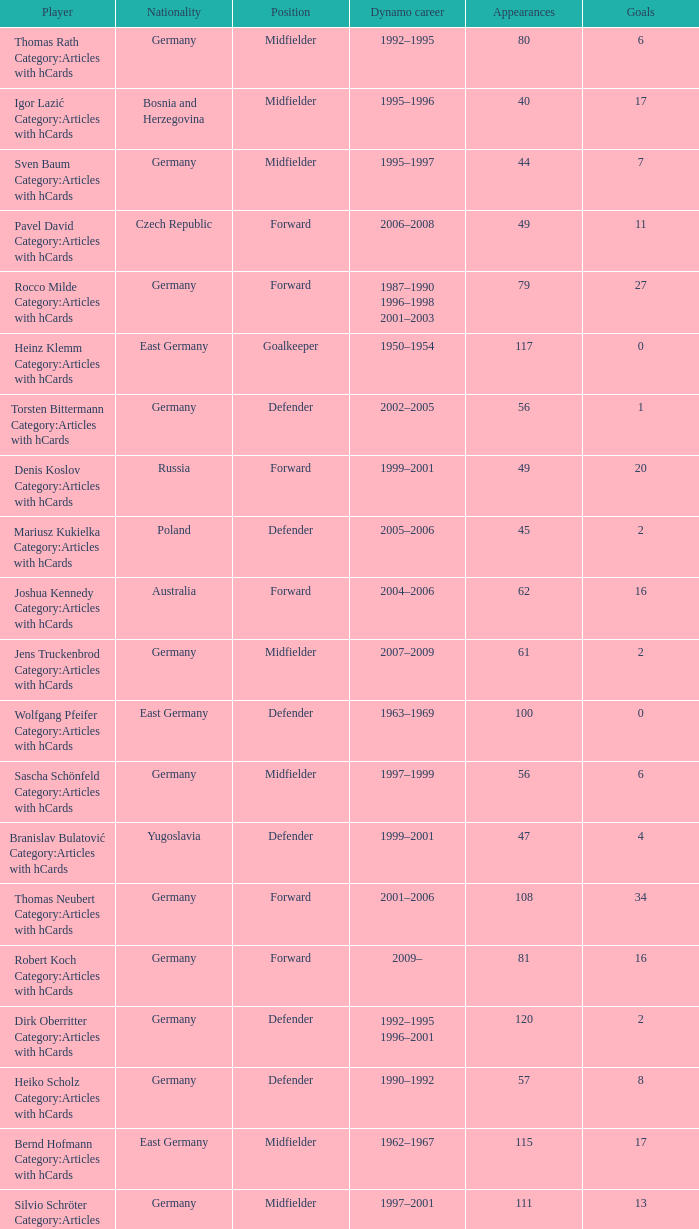Could you parse the entire table as a dict? {'header': ['Player', 'Nationality', 'Position', 'Dynamo career', 'Appearances', 'Goals'], 'rows': [['Thomas Rath Category:Articles with hCards', 'Germany', 'Midfielder', '1992–1995', '80', '6'], ['Igor Lazić Category:Articles with hCards', 'Bosnia and Herzegovina', 'Midfielder', '1995–1996', '40', '17'], ['Sven Baum Category:Articles with hCards', 'Germany', 'Midfielder', '1995–1997', '44', '7'], ['Pavel David Category:Articles with hCards', 'Czech Republic', 'Forward', '2006–2008', '49', '11'], ['Rocco Milde Category:Articles with hCards', 'Germany', 'Forward', '1987–1990 1996–1998 2001–2003', '79', '27'], ['Heinz Klemm Category:Articles with hCards', 'East Germany', 'Goalkeeper', '1950–1954', '117', '0'], ['Torsten Bittermann Category:Articles with hCards', 'Germany', 'Defender', '2002–2005', '56', '1'], ['Denis Koslov Category:Articles with hCards', 'Russia', 'Forward', '1999–2001', '49', '20'], ['Mariusz Kukielka Category:Articles with hCards', 'Poland', 'Defender', '2005–2006', '45', '2'], ['Joshua Kennedy Category:Articles with hCards', 'Australia', 'Forward', '2004–2006', '62', '16'], ['Jens Truckenbrod Category:Articles with hCards', 'Germany', 'Midfielder', '2007–2009', '61', '2'], ['Wolfgang Pfeifer Category:Articles with hCards', 'East Germany', 'Defender', '1963–1969', '100', '0'], ['Sascha Schönfeld Category:Articles with hCards', 'Germany', 'Midfielder', '1997–1999', '56', '6'], ['Branislav Bulatović Category:Articles with hCards', 'Yugoslavia', 'Defender', '1999–2001', '47', '4'], ['Thomas Neubert Category:Articles with hCards', 'Germany', 'Forward', '2001–2006', '108', '34'], ['Robert Koch Category:Articles with hCards', 'Germany', 'Forward', '2009–', '81', '16'], ['Dirk Oberritter Category:Articles with hCards', 'Germany', 'Defender', '1992–1995 1996–2001', '120', '2'], ['Heiko Scholz Category:Articles with hCards', 'Germany', 'Defender', '1990–1992', '57', '8'], ['Bernd Hofmann Category:Articles with hCards', 'East Germany', 'Midfielder', '1962–1967', '115', '17'], ['Silvio Schröter Category:Articles with hCards', 'Germany', 'Midfielder', '1997–2001', '111', '13'], ['Ulf Kirsten Category:Articles with hCards', 'East Germany', 'Forward', '1983–1990', '154', '57'], ['Hartmut Schade Category:Articles with hCards', 'East Germany', 'Midfielder', '1973–1984', '198', '34'], ['Matthias Sammer Category:Articles with hCards', 'East Germany', 'Midfielder', '1985–1990', '102', '39'], ['Markus Knackmuß Category:Articles with hCards', 'Germany', 'Midfielder', '2006–2008', '43', '1'], ['Frank Paulus Category:Articles with hCards', 'Germany', 'Defender', '1999–2003', '122', '0'], ['Erhard Haufe Category:Articles with hCards', 'East Germany', 'Defender', '1951–1954', '73', '0'], ['Daniel Petrowsky Category:Articles with hCards', 'Germany', 'Midfielder', '1999–2003', '89', '1'], ['Peter Noske Category:Articles with hCards', 'East Germany', 'Goalkeeper', '1962–1966', '61', '0'], ['Ronny Scholze Category:Articles with hCards', 'Germany', 'Midfielder', '2003–2005', '45', '5'], ['Levente Csik Category:Articles with hCards', 'Romania', 'Defender', '2001–2007', '157', '4'], ['David Solga Category:Articles with hCards', 'Germany', 'Midfielder', '2009–', '48', '2'], ['Klaus Engels Category:Articles with hCards', 'East Germany', 'Forward', '1965–1968', '61', '17'], ['Dirk Zander Category:Articles with hCards', 'Germany', 'Defender', '1991–1993', '43', '11'], ['Andreas Diebitz Category:Articles with hCards', 'East Germany', 'Defender', '1986–1990', '61', '1'], ['Peter Kotte Category:Articles with hCards', 'East Germany', 'Forward', '1973–1980', '156', '53'], ['Detlef Schößler Category:Articles with hCards', 'East Germany', 'Defender', '1989–1995', '150', '4'], ['Stanislav Cherchesov Category:Articles with hCards', 'Russia', 'Goalkeeper', '1993–1995', '62', '0'], ['Lutz Schülbe Category:Articles with hCards', 'East Germany', 'Forward', '1981–1984', '58', '11'], ['Hans-Jürgen Kreische Category:Articles with hCards', 'East Germany', 'Forward', '1964–1977', '256', '143'], ['Mario Kern Category:Articles with hCards', 'Germany', 'Defender', '1988–1995 1996', '84', '4'], ['Sebastian Pelzer Category:Articles with hCards', 'Germany', 'Defender', '2006–2008', '64', '1'], ['Uwe Rösler Category:Articles with hCards', 'Germany', 'Forward', '1991–1992 1993–1994', '53', '7'], ['Andreas Mittag Category:Articles with hCards', 'East Germany', 'Defender', '1980–1983', '40', '1'], ['Matthias Maucksch Category:Articles with hCards', 'Germany', 'Midfielder', '1987–1995', '167', '4'], ['Maik Kegel Category:Articles with hCards', 'Germany', 'Midfielder', '2007–2012', '89', '8'], ['Sven Ratke Category:Articles with hCards', 'Germany', 'Midfielder', '1989–1995 2002–2004', '108', '2'], ['Falk Terjek Category:Articles with hCards', 'Germany', 'Midfielder', '1996–1999', '64', '11'], ['Frank Kaiser Category:Articles with hCards', 'Germany', 'Midfielder', '1996–2000', '86', '5'], ['Cristian Fiél Category:Articles with hCards', 'Spain', 'Midfielder', '2010–', '43', '1'], ['Thomas Hübener Category:Articles with hCards', 'Germany', 'Defender', '2007–2011', '120', '2'], ['Dieter Riedel Category:Articles with hCards', 'East Germany', 'Forward', '1967–1980', '211', '49'], ['Dexter Langen Category:Articles with hCards', 'Germany', 'Defender', '2003–2006', '93', '3'], ['Volker Oppitz Category:Articles with hCards', 'Germany', 'Defender', '2001–2010', '226', '6'], ['Frank Lippmann Category:Articles with hCards', 'East Germany', 'Forward', '1980–1986', '89', '9'], ['Marek Penksa Category:Articles with hCards', 'Slovakia', 'Midfielder', '1993–1994 2007–2008', '60', '8'], ['Siegmar Wätzlich Category:Articles with hCards', 'East Germany', 'Defender', '1967–1975', '139', '10'], ['Matthias Müller Category:Articles with hCards', 'East Germany', 'Defender', '1974–1980', '89', '11'], ['Frank Richter Category:Articles with hCards', 'East Germany', 'Forward', '1969–1980', '127', '20'], ['Axel Keller Category:Articles with hCards', 'Germany', 'Goalkeeper', '2008–2011', '96', '0'], ['Jonas Strifler Category:Articles with hCards', 'Germany', 'Defender', '2009–2011', '53', '0'], ['Dario Dabac Category:Articles with hCards', 'Croatia', 'Defender', '2001–2003', '60', '1'], ['Steffen Heidrich Category:Articles with hCards', 'East Germany', 'Midfielder', '2001–2005', '93', '23'], ['Thomas Köhler Category:Articles with hCards', 'Germany', 'Goalkeeper', '1989–1991 1995–1999', '89', '1'], ['Ranisav Jovanović Category:Articles with hCards', 'Yugoslavia', 'Forward', '2002–2004', '70', '17'], ['Alexander Ludwig Category:Articles with hCards', 'Germany', 'Midfielder', '2005–2007', '49', '14'], ['Gerhard Hänsicke Category:Articles with hCards', 'East Germany', 'Forward', '1951–1954', '71', '39'], ['Karl-Heinz Holze Category:Articles with hCards', 'East Germany', 'Forward', '1950–1954', '86', '29'], ['Gert Heidler Category:Articles with hCards', 'East Germany', 'Midfielder', '1968–1982', '267', '49'], ['Ronny Nikol Category:Articles with hCards', 'Germany', 'Defender', '2007–2010', '85', '1'], ['Ralf Minge Category:Articles with hCards', 'East Germany', 'Forward', '1980–1991', '222', '103'], ['Cataldo Cozza Category:Articles with hCards', 'Germany', 'Defender', '2007–2010', '74', '0'], ['Siegfried Gumz Category:Articles with hCards', 'East Germany', 'Forward', '1962–1969', '120', '33'], ['René Beuchel Category:Articles with hCards', 'Germany', 'Midfielder', '1992–1995 2002–2007', '172', '16'], ['Rainer Sachse Category:Articles with hCards', 'East Germany', 'Forward', '1970–1980', '172', '70'], ['Christian Helm Category:Articles with hCards', 'East Germany', 'Defender', '1972–1982', '188', '3'], ['Daniel Ernemann Category:Articles with hCards', 'Germany', 'Defender', '2006–2008', '62', '3'], ['Klaus Sammer Category:Articles with hCards', 'East Germany', 'Midfielder', '1965–1974', '183', '27'], ['Frank Schuster Category:Articles with hCards', 'East Germany', 'Defender', '1981–1985', '91', '2'], ['Markus Palionis Category:Articles with hCards', 'Lithuania', 'Defender', '2008–2010', '57', '0'], ['Stefan Bernhardt Category:Articles with hCards', 'Germany', 'Midfielder', '1996–1999', '56', '1'], ['Thomas Bröker Category:Articles with hCards', 'Germany', 'Forward', '2005–2006 2007–2009', '97', '23'], ['Klaus Müller Category:Articles with hCards', 'East Germany', 'Defender', '1973–1980 1980–1981', '87', '9'], ['Herbert Schoen Category:Articles with hCards', 'East Germany', 'Defender', '1950–1954', '133', '2'], ['Bernd Jakubowski Category:Articles with hCards', 'East Germany', 'Goalkeeper', '1977–1986', '183', '0'], ['Gerd Weber Category:Articles with hCards', 'East Germany', 'Midfielder', '1973–1980', '145', '44'], ['René Müller Category:Articles with hCards', 'East Germany', 'Goalkeeper', '1991–1994', '84', '0'], ['Wolfgang Oeser Category:Articles with hCards', 'East Germany', 'Midfielder', '1962–1966', '73', '7'], ['René Groth Category:Articles with hCards', 'Germany', 'Defender', '1992–1995 1997–2000', '54', '0'], ['Andreas Schmidt Category:Articles with hCards', 'East Germany', 'Defender', '1980–1985', '70', '2'], ['Thomas Hoßmang Category:Articles with hCards', 'Germany', 'Defender', '1994–1996', '47', '2'], ['Meinhard Hemp Category:Articles with hCards', 'East Germany', 'Midfielder', '1963–1972', '102', '6'], ['Jens Melzig Category:Articles with hCards', 'Germany', 'Defender', '1991–1993', '65', '3'], ['Jens Wahl Category:Articles with hCards', 'East Germany', 'Defender', '1997–2000', '56', '6'], ['Gerrit Müller Category:Articles with hCards', 'Germany', 'Midfielder', '2008–2012', '85', '8'], ['Timo Röttger Category:Articles with hCards', 'Germany', 'Midfielder', '2008–2011', '63', '9'], ['Horst Rau Category:Articles with hCards', 'East Germany', 'Midfielder', '1969–1974', '82', '11'], ['Marco Vorbeck Category:Articles with hCards', 'Germany', 'Forward', '2005–2007', '60', '19'], ['Frank Ganzera Category:Articles with hCards', 'East Germany', 'Defender', '1966–1976', '133', '8'], ['Kurt Fischer Category:Articles with hCards', 'East Germany', 'Midfielder', '1950–1954', '126', '3'], ['Andreas Wagenhaus Category:Articles with hCards', 'East Germany', 'Defender', '1989–1993', '89', '4'], ['Jörg Stübner Category:Articles with hCards', 'East Germany', 'Midfielder', '1983–1993', '182', '14'], ['Jens Reckmann Category:Articles with hCards', 'Germany', 'Defender', '1997–1999', '60', '1'], ['Rico Hanke Category:Articles with hCards', 'Germany', 'Forward', '1995–2000', '112', '22'], ['Markus Kranz Category:Articles with hCards', 'Germany', 'Midfielder', '1993–1995', '57', '3'], ['Frank Lieberam Category:Articles with hCards', 'Germany', 'Defender', '1986–1991', '154', '10'], ['Ralf Möbius Category:Articles with hCards', 'East Germany', 'Forward', '1950–1954', '129', '39'], ['Oliver Herber Category:Articles with hCards', 'Germany', 'Goalkeeper', '2003–2008', '51', '0'], ['Claus Boden Category:Articles with hCards', 'East Germany', 'Goalkeeper', '1971–1981', '153', '0'], ['Eduard Geyer Category:Articles with hCards', 'East Germany', 'Defender', '1969–1975', '90', '6'], ['Ralf Hauptmann Category:Articles with hCards', 'East Germany', 'Midfielder', '1987–1993', '127', '5'], ['Sebastian Hähnge Category:Articles with hCards', 'Germany', 'Forward', '2000–2003', '66', '16'], ['Pavel Dobry Category:Articles with hCards', 'Czech Republic', 'Forward', '2007–2010', '96', '23'], ['Horst Walter Category:Articles with hCards', 'East Germany', 'Midfielder', '1966–1969', '45', '1'], ['Uwe Jähnig Category:Articles with hCards', 'Germany', 'Midfielder', '1987–1995', '129', '16'], ['Sascha Pfeffer Category:Articles with hCards', 'Germany', 'Midfielder', '2007–2012', '88', '1'], ['Steffen Büttner Category:Articles with hCards', 'Germany', 'Defender', '1985–1992', '121', '3'], ['Lars Heller Category:Articles with hCards', 'Germany', 'Defender', '2001–2004', '83', '0'], ['Daniel Ziebig Category:Articles with hCards', 'Germany', 'Midfielder', '2001–2005', '74', '1'], ['Gerhard Prautzsch Category:Articles with hCards', 'East Germany', 'Defender', '1962–1966', '92', '4'], ['Ignjac Krešić Category:Articles with hCards', 'Croatia', 'Goalkeeper', '1999–2006', '217', '0'], ['Ivo Ulich Category:Articles with hCards', 'Czech Republic', 'Midfielder', '2005–2008', '78', '12'], ['Antoni Jelen Category:Articles with hCards', 'Poland', 'Midfielder', '1995–2000', '110', '2'], ['Matthias Döschner Category:Articles with hCards', 'East Germany', 'Midfielder', '1978–1990', '253', '32'], ['Wolfgang Haustein Category:Articles with hCards', 'East Germany', 'Defender', '1962–1973', '181', '1'], ['Johannes Matzen Category:Articles with hCards', 'East Germany', 'Forward', '1950–1954', '138', '46'], ['Hans-Uwe Pilz Category:Articles with hCards', 'East Germany', 'Midfielder', '1982–1990 1990–1995', '299', '35'], ['Vladimir Manislavić Category:Articles with hCards', 'Yugoslavia', 'Forward', '1999–2001', '49', '15'], ['Udo Schmuck Category:Articles with hCards', 'East Germany', 'Defender', '1972–1985', '263', '33'], ['Lars Jungnickel Category:Articles with hCards', 'Germany', 'Midfielder', '1999–2001 2007–', '151', '17'], ['Karsten Oswald Category:Articles with hCards', 'Germany', 'Midfielder', '2004–2006', '45', '4'], ['Matthias Großmann Category:Articles with hCards', 'Germany', 'Midfielder', '1997–2001', '89', '7'], ['Karsten Petersohn Category:Articles with hCards', 'East Germany', 'Midfielder', '1977–1983', '40', '6'], ['Miroslav Stević Category:Articles with hCards', 'Yugoslavia', 'Midfielder', '1992–1994', '60', '5'], ['Günther Usemann Category:Articles with hCards', 'East Germany', 'Midfielder', '1950–1954', '121', '8'], ['Christian Fröhlich Category:Articles with hCards', 'Germany', 'Midfielder', '1995–1996 2003–2005', '91', '19'], ['Jörg Schmidt Category:Articles with hCards', 'Germany', 'Midfielder', '1996–1998', '52', '11'], ['Reinhard Häfner Category:Articles with hCards', 'East Germany', 'Midfielder', '1971–1988', '366', '49'], ['Christian Hauser Category:Articles with hCards', 'Germany', 'Midfielder', '2004–2008', '73', '1'], ['Michael Lerchl Category:Articles with hCards', 'Germany', 'Midfielder', '2005–2007', '43', '0'], ['Erich Siede Category:Articles with hCards', 'East Germany', 'Forward', '1962–1966', '54', '7'], ['Florian Jungwirth Category:Articles with hCards', 'Germany', 'Defender', '2010–', '59', '0'], ['Horst Beulig Category:Articles with hCards', 'East Germany', 'Midfielder', '1950–1953', '43', '0'], ['Maik Wagefeld Category:Articles with hCards', 'Germany', 'Midfielder', '1999–2004 2006 2007–2011', '257', '32'], ['Ronny Teuber Category:Articles with hCards', 'East Germany', 'Goalkeeper', '1986–1993', '110', '0'], ['Torsten Gütschow Category:Articles with hCards', 'East Germany', 'Forward', '1980–1992 1996–1999', '329', '149'], ['Günter Schröter Category:Articles with hCards', 'East Germany', 'Forward', '1950–1954', '137', '78'], ['Halil Savran Category:Articles with hCards', 'Germany', 'Striker', '2008–2010', '69', '26'], ['Manfred Michael Category:Articles with hCards', 'East Germany', 'Defender', '1950–1954', '124', '7'], ['Martin Stocklasa Category:Articles with hCards', 'Liechtenstein', 'Defender', '2006–2008', '66', '2'], ['Andreas Trautmann Category:Articles with hCards', 'East Germany', 'Midfielder', '1977–1990 1990–1991', '270', '48'], ['Hans-Jürgen Dörner Category:Articles with hCards', 'East Germany', 'Midfielder', '1969–1986', '392', '65'], ['Steffen Engelmohr Category:Articles with hCards', 'East Germany', 'Defender', '1963–1968', '63', '12'], ['Manfred Kallenbach Category:Articles with hCards', 'East Germany', 'Goalkeeper', '1966–1972', '105', '0'], ['Sven Kmetsch Category:Articles with hCards', 'Germany', 'Midfielder', '1989–1995', '102', '7']]} What was the position of the player with 57 goals? Forward. 